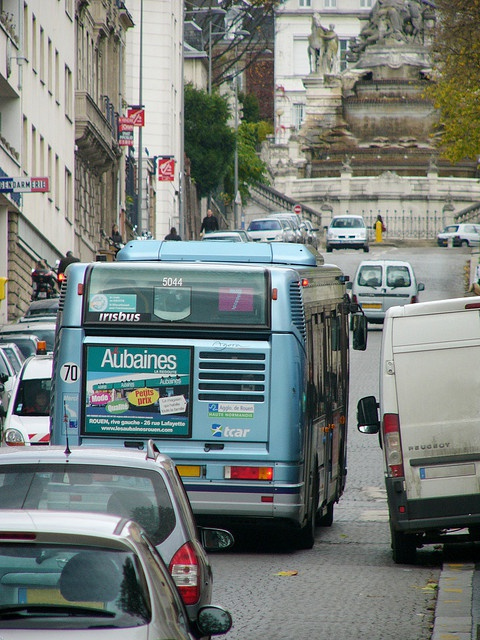Describe the objects in this image and their specific colors. I can see bus in black, gray, and darkgray tones, car in black, darkgray, lightgray, and gray tones, truck in black, darkgray, lightgray, and gray tones, car in black, gray, teal, and lightgray tones, and car in black, gray, and darkgray tones in this image. 